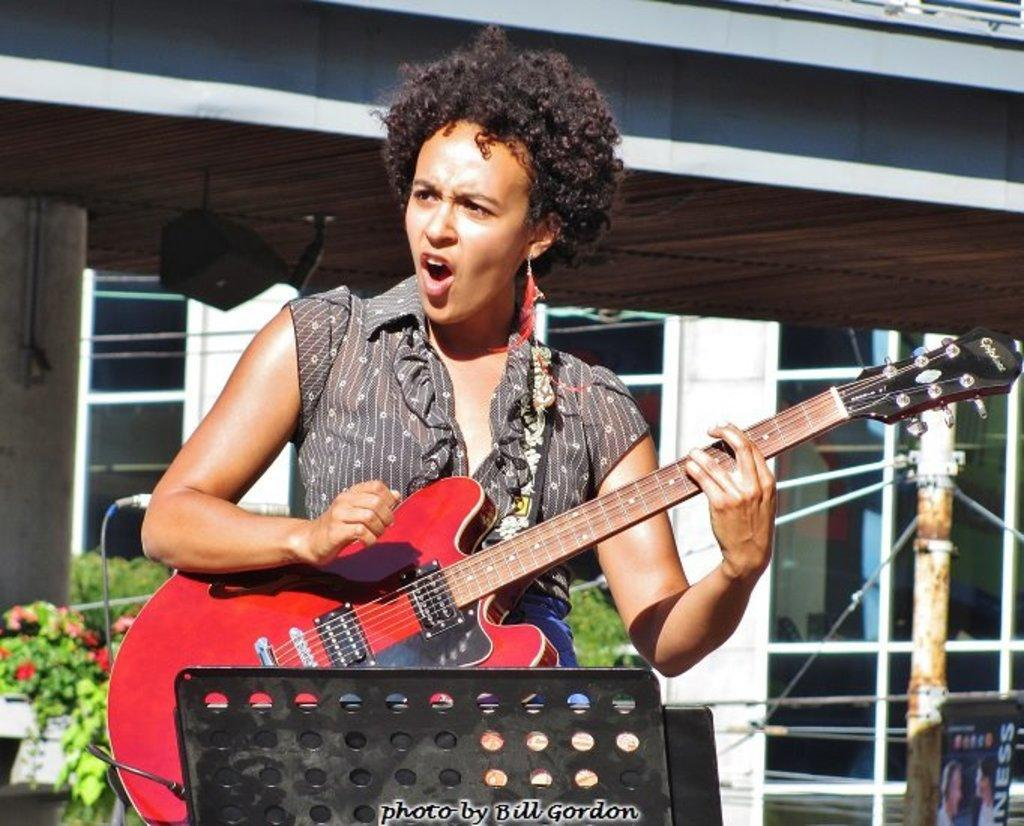What is the main subject of the image? There is a woman in the image. What is the woman doing in the image? The woman is standing, playing a guitar, and singing. What can be seen in the background of the image? There is a building in the background of the image. What type of vegetation is present in the image? There are plants in the bottom left side of the image. What type of skate is the woman using to play the guitar in the image? There is no skate present in the image, and the woman is not using any skate to play the guitar. What message is conveyed by the sign in the image? There is no sign present in the image, so no message can be conveyed. 